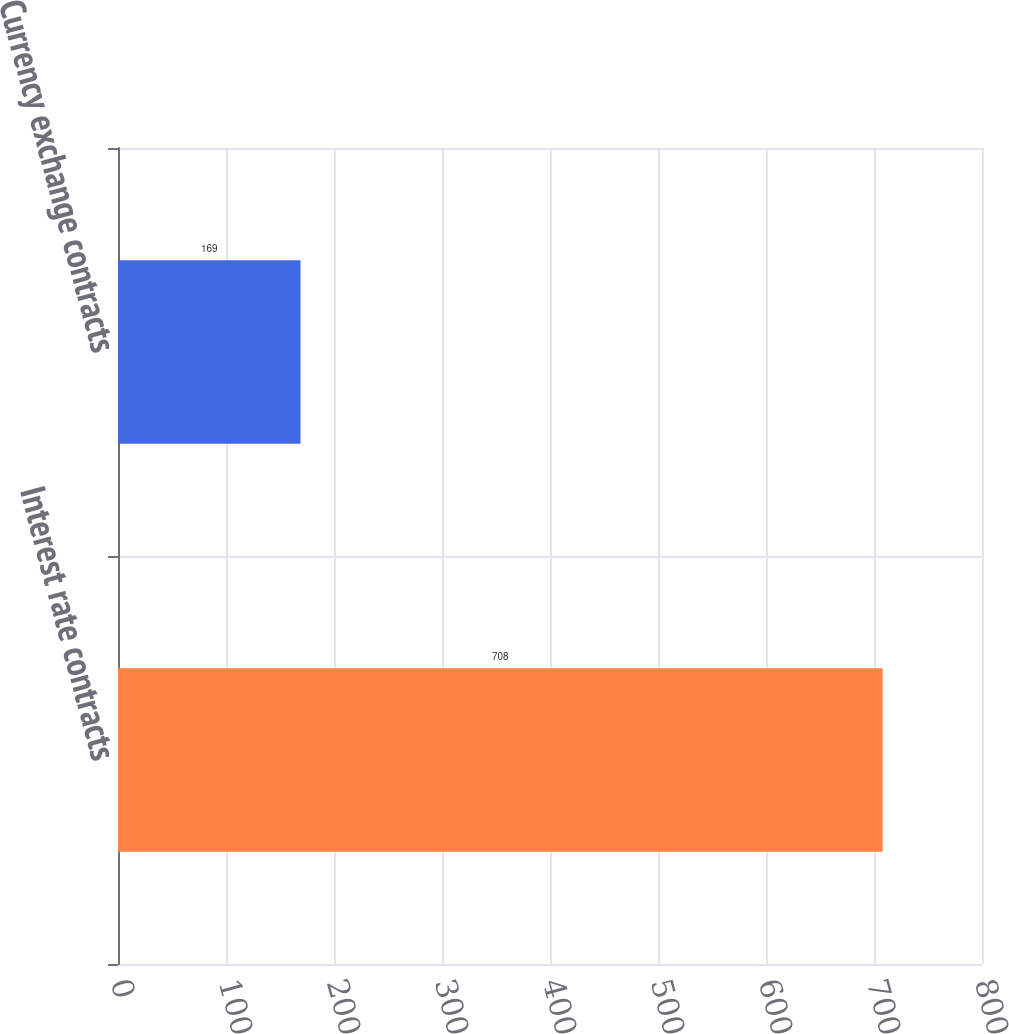<chart> <loc_0><loc_0><loc_500><loc_500><bar_chart><fcel>Interest rate contracts<fcel>Currency exchange contracts<nl><fcel>708<fcel>169<nl></chart> 